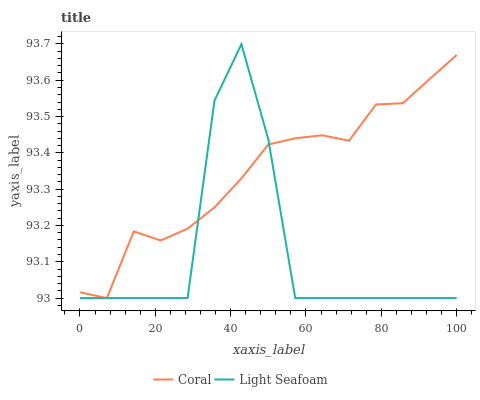Does Light Seafoam have the minimum area under the curve?
Answer yes or no. Yes. Does Coral have the maximum area under the curve?
Answer yes or no. Yes. Does Light Seafoam have the maximum area under the curve?
Answer yes or no. No. Is Coral the smoothest?
Answer yes or no. Yes. Is Light Seafoam the roughest?
Answer yes or no. Yes. Is Light Seafoam the smoothest?
Answer yes or no. No. 